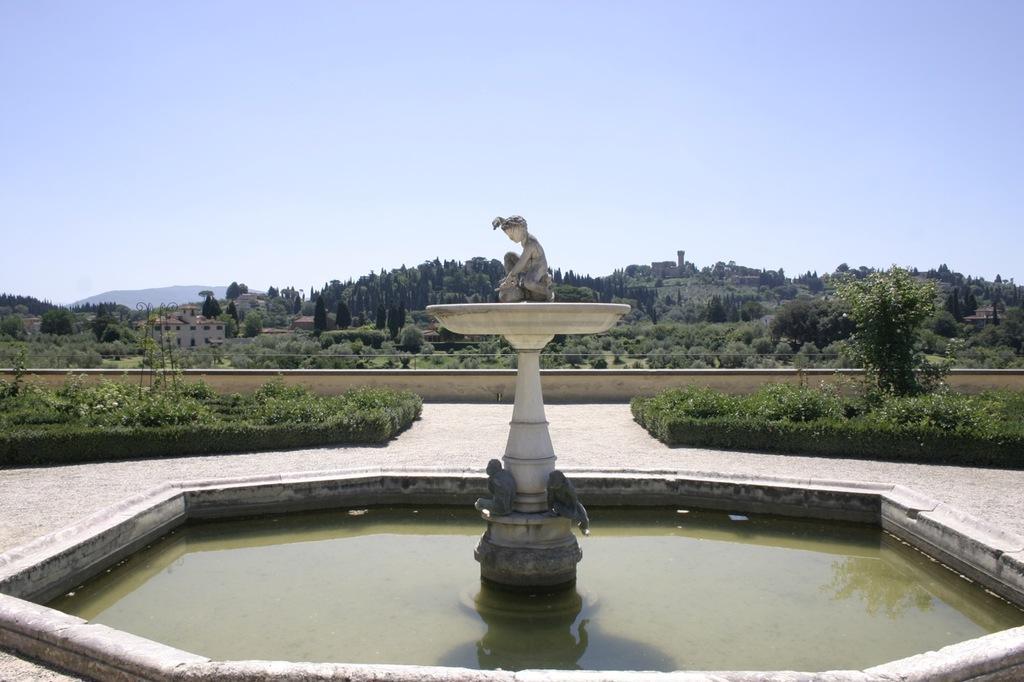How would you summarize this image in a sentence or two? In this image there is a fountain in water. There is a statue on fountain. There are few plants beside the floor. Behind the wall there is a building and few trees are on the land. Left side of image there is hill. Top of image there is sky. 